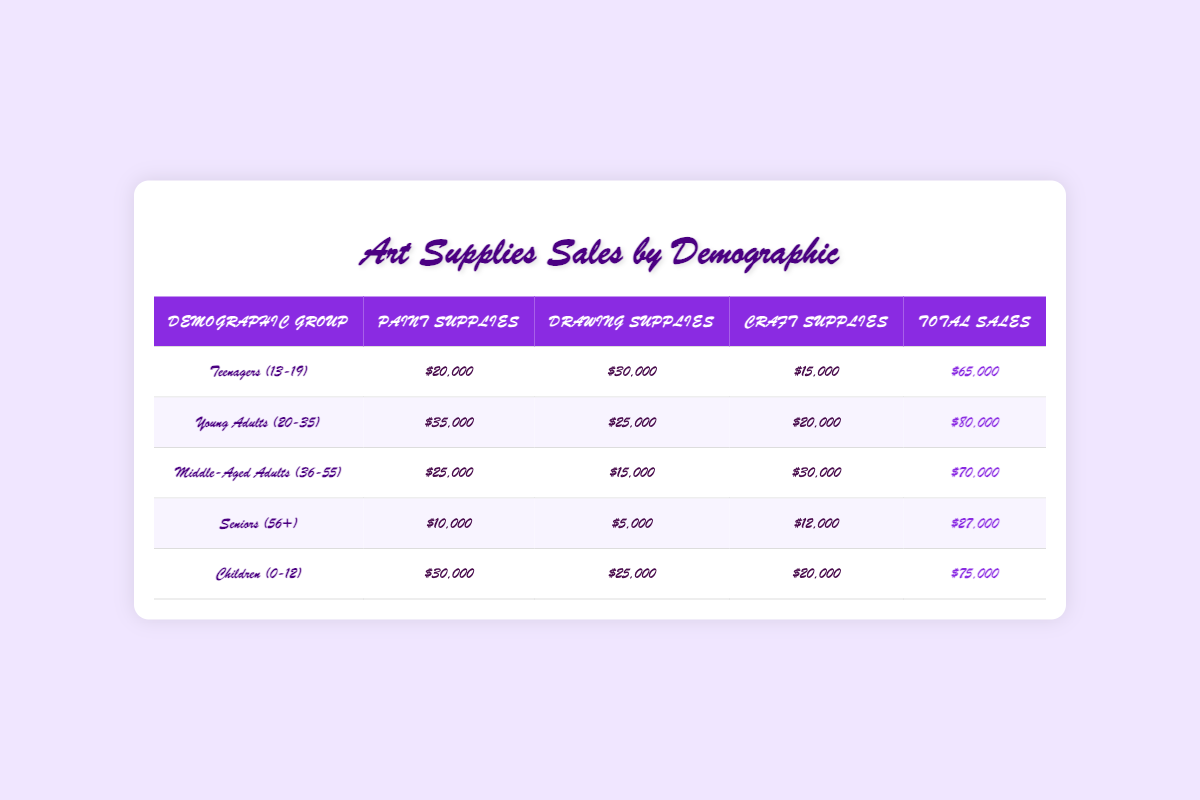What is the total sales for Young Adults (20-35)? The total sales for Young Adults (20-35) is listed directly in the table. It shows $80,000 as the total sales for this demographic group.
Answer: $80,000 Which demographic group has the highest sales of drawing supplies? By comparing the drawing supplies sales of each demographic group, Young Adults (20-35) has the highest sales at $25,000.
Answer: Young Adults (20-35) What is the difference in total sales between Teenagers (13-19) and Seniors (56+)? Teenagers (13-19) have total sales of $65,000, and Seniors (56+) have total sales of $27,000. The difference is $65,000 - $27,000 = $38,000.
Answer: $38,000 Is it true that Middle-Aged Adults (36-55) sell more paint supplies than Seniors (56+)? Yes, Middle-Aged Adults (36-55) sold $25,000 in paint supplies while Seniors (56+) only sold $10,000 in paint supplies, confirming the statement is true.
Answer: Yes What is the average total sales across all demographic groups? To find the average total sales, we add all total sales: $65,000 + $80,000 + $70,000 + $27,000 + $75,000 = $317,000. We then divide this by the number of groups (5): $317,000 / 5 = $63,400.
Answer: $63,400 What are the total craft supplies sales for Children (0-12) and Seniors (56+) combined? Children (0-12) sold $20,000 and Seniors (56+) sold $12,000 in craft supplies. Summing these gives $20,000 + $12,000 = $32,000.
Answer: $32,000 Which demographic group has the least total sales? The table shows that Seniors (56+) have the least total sales of $27,000 compared to all other groups.
Answer: Seniors (56+) How much more do Young Adults (20-35) spend on paint supplies compared to Middle-Aged Adults (36-55)? Young Adults (20-35) have paint supplies sales of $35,000, while Middle-Aged Adults (36-55) have $25,000. The difference is $35,000 - $25,000 = $10,000.
Answer: $10,000 